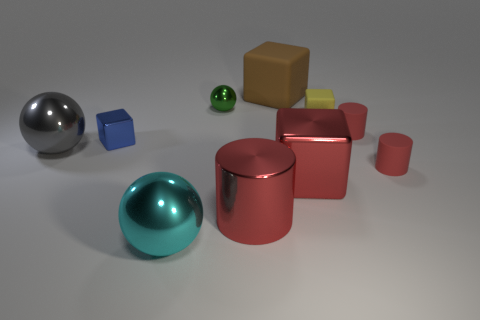Subtract 1 cubes. How many cubes are left? 3 Subtract all gray blocks. Subtract all green balls. How many blocks are left? 4 Subtract all balls. How many objects are left? 7 Add 8 small yellow matte blocks. How many small yellow matte blocks are left? 9 Add 7 large yellow blocks. How many large yellow blocks exist? 7 Subtract 0 purple blocks. How many objects are left? 10 Subtract all tiny cyan metal cylinders. Subtract all red metallic cylinders. How many objects are left? 9 